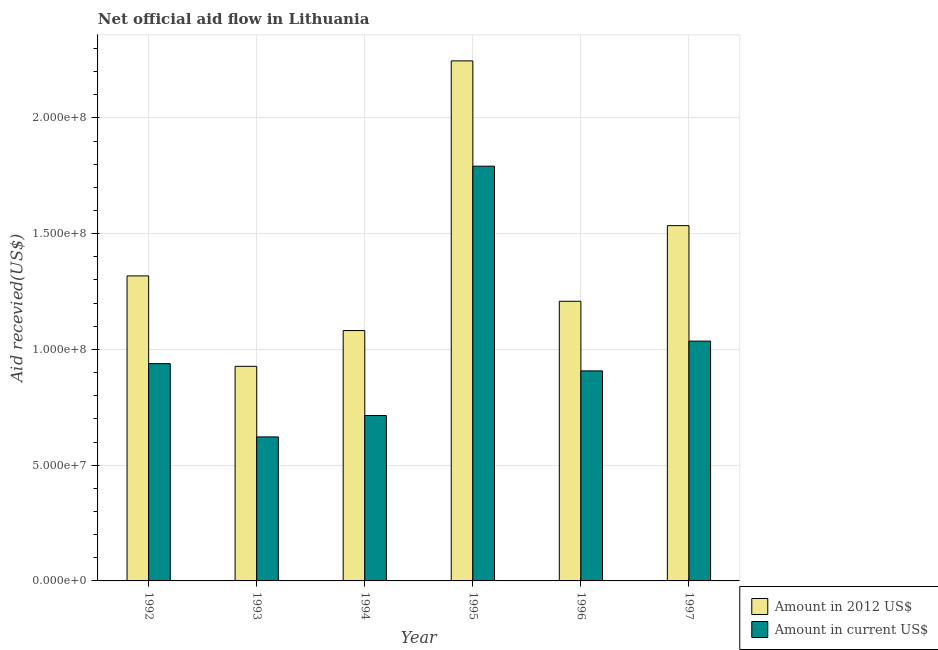How many different coloured bars are there?
Give a very brief answer. 2. Are the number of bars on each tick of the X-axis equal?
Make the answer very short. Yes. What is the label of the 4th group of bars from the left?
Keep it short and to the point. 1995. In how many cases, is the number of bars for a given year not equal to the number of legend labels?
Provide a short and direct response. 0. What is the amount of aid received(expressed in us$) in 1993?
Your answer should be very brief. 6.22e+07. Across all years, what is the maximum amount of aid received(expressed in 2012 us$)?
Make the answer very short. 2.25e+08. Across all years, what is the minimum amount of aid received(expressed in 2012 us$)?
Provide a short and direct response. 9.27e+07. In which year was the amount of aid received(expressed in 2012 us$) maximum?
Provide a short and direct response. 1995. In which year was the amount of aid received(expressed in us$) minimum?
Ensure brevity in your answer.  1993. What is the total amount of aid received(expressed in us$) in the graph?
Keep it short and to the point. 6.01e+08. What is the difference between the amount of aid received(expressed in us$) in 1994 and that in 1997?
Your answer should be very brief. -3.22e+07. What is the difference between the amount of aid received(expressed in 2012 us$) in 1992 and the amount of aid received(expressed in us$) in 1995?
Make the answer very short. -9.29e+07. What is the average amount of aid received(expressed in 2012 us$) per year?
Your answer should be compact. 1.39e+08. What is the ratio of the amount of aid received(expressed in us$) in 1995 to that in 1997?
Your answer should be compact. 1.73. Is the amount of aid received(expressed in 2012 us$) in 1992 less than that in 1995?
Provide a succinct answer. Yes. Is the difference between the amount of aid received(expressed in us$) in 1994 and 1996 greater than the difference between the amount of aid received(expressed in 2012 us$) in 1994 and 1996?
Ensure brevity in your answer.  No. What is the difference between the highest and the second highest amount of aid received(expressed in 2012 us$)?
Provide a succinct answer. 7.12e+07. What is the difference between the highest and the lowest amount of aid received(expressed in us$)?
Provide a short and direct response. 1.17e+08. In how many years, is the amount of aid received(expressed in us$) greater than the average amount of aid received(expressed in us$) taken over all years?
Your answer should be very brief. 2. Is the sum of the amount of aid received(expressed in us$) in 1992 and 1993 greater than the maximum amount of aid received(expressed in 2012 us$) across all years?
Your response must be concise. No. What does the 2nd bar from the left in 1993 represents?
Your answer should be compact. Amount in current US$. What does the 2nd bar from the right in 1993 represents?
Make the answer very short. Amount in 2012 US$. How many bars are there?
Provide a short and direct response. 12. Are all the bars in the graph horizontal?
Your response must be concise. No. What is the difference between two consecutive major ticks on the Y-axis?
Provide a succinct answer. 5.00e+07. Does the graph contain any zero values?
Your answer should be very brief. No. How many legend labels are there?
Offer a very short reply. 2. How are the legend labels stacked?
Keep it short and to the point. Vertical. What is the title of the graph?
Ensure brevity in your answer.  Net official aid flow in Lithuania. Does "Primary" appear as one of the legend labels in the graph?
Your response must be concise. No. What is the label or title of the Y-axis?
Ensure brevity in your answer.  Aid recevied(US$). What is the Aid recevied(US$) in Amount in 2012 US$ in 1992?
Your answer should be very brief. 1.32e+08. What is the Aid recevied(US$) in Amount in current US$ in 1992?
Give a very brief answer. 9.38e+07. What is the Aid recevied(US$) of Amount in 2012 US$ in 1993?
Offer a very short reply. 9.27e+07. What is the Aid recevied(US$) of Amount in current US$ in 1993?
Make the answer very short. 6.22e+07. What is the Aid recevied(US$) in Amount in 2012 US$ in 1994?
Offer a terse response. 1.08e+08. What is the Aid recevied(US$) in Amount in current US$ in 1994?
Your response must be concise. 7.14e+07. What is the Aid recevied(US$) in Amount in 2012 US$ in 1995?
Your response must be concise. 2.25e+08. What is the Aid recevied(US$) in Amount in current US$ in 1995?
Make the answer very short. 1.79e+08. What is the Aid recevied(US$) of Amount in 2012 US$ in 1996?
Your answer should be compact. 1.21e+08. What is the Aid recevied(US$) of Amount in current US$ in 1996?
Make the answer very short. 9.07e+07. What is the Aid recevied(US$) of Amount in 2012 US$ in 1997?
Offer a terse response. 1.53e+08. What is the Aid recevied(US$) of Amount in current US$ in 1997?
Offer a very short reply. 1.04e+08. Across all years, what is the maximum Aid recevied(US$) in Amount in 2012 US$?
Your answer should be very brief. 2.25e+08. Across all years, what is the maximum Aid recevied(US$) in Amount in current US$?
Offer a terse response. 1.79e+08. Across all years, what is the minimum Aid recevied(US$) of Amount in 2012 US$?
Make the answer very short. 9.27e+07. Across all years, what is the minimum Aid recevied(US$) in Amount in current US$?
Provide a succinct answer. 6.22e+07. What is the total Aid recevied(US$) of Amount in 2012 US$ in the graph?
Offer a very short reply. 8.31e+08. What is the total Aid recevied(US$) of Amount in current US$ in the graph?
Provide a succinct answer. 6.01e+08. What is the difference between the Aid recevied(US$) of Amount in 2012 US$ in 1992 and that in 1993?
Provide a short and direct response. 3.91e+07. What is the difference between the Aid recevied(US$) of Amount in current US$ in 1992 and that in 1993?
Your answer should be compact. 3.16e+07. What is the difference between the Aid recevied(US$) in Amount in 2012 US$ in 1992 and that in 1994?
Your response must be concise. 2.36e+07. What is the difference between the Aid recevied(US$) in Amount in current US$ in 1992 and that in 1994?
Keep it short and to the point. 2.24e+07. What is the difference between the Aid recevied(US$) of Amount in 2012 US$ in 1992 and that in 1995?
Provide a succinct answer. -9.29e+07. What is the difference between the Aid recevied(US$) in Amount in current US$ in 1992 and that in 1995?
Offer a very short reply. -8.53e+07. What is the difference between the Aid recevied(US$) of Amount in 2012 US$ in 1992 and that in 1996?
Ensure brevity in your answer.  1.10e+07. What is the difference between the Aid recevied(US$) in Amount in current US$ in 1992 and that in 1996?
Ensure brevity in your answer.  3.13e+06. What is the difference between the Aid recevied(US$) in Amount in 2012 US$ in 1992 and that in 1997?
Make the answer very short. -2.17e+07. What is the difference between the Aid recevied(US$) in Amount in current US$ in 1992 and that in 1997?
Offer a very short reply. -9.73e+06. What is the difference between the Aid recevied(US$) of Amount in 2012 US$ in 1993 and that in 1994?
Provide a short and direct response. -1.54e+07. What is the difference between the Aid recevied(US$) of Amount in current US$ in 1993 and that in 1994?
Keep it short and to the point. -9.23e+06. What is the difference between the Aid recevied(US$) in Amount in 2012 US$ in 1993 and that in 1995?
Make the answer very short. -1.32e+08. What is the difference between the Aid recevied(US$) in Amount in current US$ in 1993 and that in 1995?
Give a very brief answer. -1.17e+08. What is the difference between the Aid recevied(US$) of Amount in 2012 US$ in 1993 and that in 1996?
Your answer should be compact. -2.81e+07. What is the difference between the Aid recevied(US$) of Amount in current US$ in 1993 and that in 1996?
Your answer should be compact. -2.85e+07. What is the difference between the Aid recevied(US$) in Amount in 2012 US$ in 1993 and that in 1997?
Provide a succinct answer. -6.08e+07. What is the difference between the Aid recevied(US$) of Amount in current US$ in 1993 and that in 1997?
Ensure brevity in your answer.  -4.14e+07. What is the difference between the Aid recevied(US$) in Amount in 2012 US$ in 1994 and that in 1995?
Provide a short and direct response. -1.16e+08. What is the difference between the Aid recevied(US$) in Amount in current US$ in 1994 and that in 1995?
Make the answer very short. -1.08e+08. What is the difference between the Aid recevied(US$) of Amount in 2012 US$ in 1994 and that in 1996?
Your answer should be very brief. -1.26e+07. What is the difference between the Aid recevied(US$) in Amount in current US$ in 1994 and that in 1996?
Make the answer very short. -1.93e+07. What is the difference between the Aid recevied(US$) in Amount in 2012 US$ in 1994 and that in 1997?
Make the answer very short. -4.53e+07. What is the difference between the Aid recevied(US$) of Amount in current US$ in 1994 and that in 1997?
Ensure brevity in your answer.  -3.22e+07. What is the difference between the Aid recevied(US$) of Amount in 2012 US$ in 1995 and that in 1996?
Provide a succinct answer. 1.04e+08. What is the difference between the Aid recevied(US$) of Amount in current US$ in 1995 and that in 1996?
Ensure brevity in your answer.  8.84e+07. What is the difference between the Aid recevied(US$) in Amount in 2012 US$ in 1995 and that in 1997?
Your answer should be compact. 7.12e+07. What is the difference between the Aid recevied(US$) of Amount in current US$ in 1995 and that in 1997?
Your answer should be compact. 7.56e+07. What is the difference between the Aid recevied(US$) in Amount in 2012 US$ in 1996 and that in 1997?
Provide a short and direct response. -3.27e+07. What is the difference between the Aid recevied(US$) in Amount in current US$ in 1996 and that in 1997?
Your answer should be very brief. -1.29e+07. What is the difference between the Aid recevied(US$) of Amount in 2012 US$ in 1992 and the Aid recevied(US$) of Amount in current US$ in 1993?
Your response must be concise. 6.96e+07. What is the difference between the Aid recevied(US$) of Amount in 2012 US$ in 1992 and the Aid recevied(US$) of Amount in current US$ in 1994?
Give a very brief answer. 6.03e+07. What is the difference between the Aid recevied(US$) in Amount in 2012 US$ in 1992 and the Aid recevied(US$) in Amount in current US$ in 1995?
Keep it short and to the point. -4.74e+07. What is the difference between the Aid recevied(US$) of Amount in 2012 US$ in 1992 and the Aid recevied(US$) of Amount in current US$ in 1996?
Provide a short and direct response. 4.10e+07. What is the difference between the Aid recevied(US$) in Amount in 2012 US$ in 1992 and the Aid recevied(US$) in Amount in current US$ in 1997?
Offer a very short reply. 2.82e+07. What is the difference between the Aid recevied(US$) of Amount in 2012 US$ in 1993 and the Aid recevied(US$) of Amount in current US$ in 1994?
Provide a short and direct response. 2.13e+07. What is the difference between the Aid recevied(US$) of Amount in 2012 US$ in 1993 and the Aid recevied(US$) of Amount in current US$ in 1995?
Keep it short and to the point. -8.64e+07. What is the difference between the Aid recevied(US$) in Amount in 2012 US$ in 1993 and the Aid recevied(US$) in Amount in current US$ in 1996?
Ensure brevity in your answer.  1.97e+06. What is the difference between the Aid recevied(US$) of Amount in 2012 US$ in 1993 and the Aid recevied(US$) of Amount in current US$ in 1997?
Your response must be concise. -1.09e+07. What is the difference between the Aid recevied(US$) of Amount in 2012 US$ in 1994 and the Aid recevied(US$) of Amount in current US$ in 1995?
Offer a very short reply. -7.10e+07. What is the difference between the Aid recevied(US$) in Amount in 2012 US$ in 1994 and the Aid recevied(US$) in Amount in current US$ in 1996?
Give a very brief answer. 1.74e+07. What is the difference between the Aid recevied(US$) of Amount in 2012 US$ in 1994 and the Aid recevied(US$) of Amount in current US$ in 1997?
Offer a terse response. 4.56e+06. What is the difference between the Aid recevied(US$) in Amount in 2012 US$ in 1995 and the Aid recevied(US$) in Amount in current US$ in 1996?
Offer a terse response. 1.34e+08. What is the difference between the Aid recevied(US$) of Amount in 2012 US$ in 1995 and the Aid recevied(US$) of Amount in current US$ in 1997?
Your answer should be compact. 1.21e+08. What is the difference between the Aid recevied(US$) in Amount in 2012 US$ in 1996 and the Aid recevied(US$) in Amount in current US$ in 1997?
Give a very brief answer. 1.72e+07. What is the average Aid recevied(US$) in Amount in 2012 US$ per year?
Offer a terse response. 1.39e+08. What is the average Aid recevied(US$) in Amount in current US$ per year?
Your answer should be very brief. 1.00e+08. In the year 1992, what is the difference between the Aid recevied(US$) in Amount in 2012 US$ and Aid recevied(US$) in Amount in current US$?
Your answer should be compact. 3.79e+07. In the year 1993, what is the difference between the Aid recevied(US$) in Amount in 2012 US$ and Aid recevied(US$) in Amount in current US$?
Provide a succinct answer. 3.05e+07. In the year 1994, what is the difference between the Aid recevied(US$) of Amount in 2012 US$ and Aid recevied(US$) of Amount in current US$?
Keep it short and to the point. 3.67e+07. In the year 1995, what is the difference between the Aid recevied(US$) of Amount in 2012 US$ and Aid recevied(US$) of Amount in current US$?
Give a very brief answer. 4.55e+07. In the year 1996, what is the difference between the Aid recevied(US$) of Amount in 2012 US$ and Aid recevied(US$) of Amount in current US$?
Your response must be concise. 3.01e+07. In the year 1997, what is the difference between the Aid recevied(US$) of Amount in 2012 US$ and Aid recevied(US$) of Amount in current US$?
Keep it short and to the point. 4.99e+07. What is the ratio of the Aid recevied(US$) in Amount in 2012 US$ in 1992 to that in 1993?
Offer a very short reply. 1.42. What is the ratio of the Aid recevied(US$) of Amount in current US$ in 1992 to that in 1993?
Give a very brief answer. 1.51. What is the ratio of the Aid recevied(US$) of Amount in 2012 US$ in 1992 to that in 1994?
Keep it short and to the point. 1.22. What is the ratio of the Aid recevied(US$) in Amount in current US$ in 1992 to that in 1994?
Provide a short and direct response. 1.31. What is the ratio of the Aid recevied(US$) in Amount in 2012 US$ in 1992 to that in 1995?
Offer a very short reply. 0.59. What is the ratio of the Aid recevied(US$) of Amount in current US$ in 1992 to that in 1995?
Give a very brief answer. 0.52. What is the ratio of the Aid recevied(US$) in Amount in 2012 US$ in 1992 to that in 1996?
Your answer should be very brief. 1.09. What is the ratio of the Aid recevied(US$) of Amount in current US$ in 1992 to that in 1996?
Keep it short and to the point. 1.03. What is the ratio of the Aid recevied(US$) of Amount in 2012 US$ in 1992 to that in 1997?
Give a very brief answer. 0.86. What is the ratio of the Aid recevied(US$) of Amount in current US$ in 1992 to that in 1997?
Your answer should be very brief. 0.91. What is the ratio of the Aid recevied(US$) in Amount in current US$ in 1993 to that in 1994?
Your response must be concise. 0.87. What is the ratio of the Aid recevied(US$) of Amount in 2012 US$ in 1993 to that in 1995?
Keep it short and to the point. 0.41. What is the ratio of the Aid recevied(US$) of Amount in current US$ in 1993 to that in 1995?
Your answer should be very brief. 0.35. What is the ratio of the Aid recevied(US$) of Amount in 2012 US$ in 1993 to that in 1996?
Provide a succinct answer. 0.77. What is the ratio of the Aid recevied(US$) of Amount in current US$ in 1993 to that in 1996?
Provide a short and direct response. 0.69. What is the ratio of the Aid recevied(US$) in Amount in 2012 US$ in 1993 to that in 1997?
Your answer should be compact. 0.6. What is the ratio of the Aid recevied(US$) in Amount in current US$ in 1993 to that in 1997?
Offer a terse response. 0.6. What is the ratio of the Aid recevied(US$) of Amount in 2012 US$ in 1994 to that in 1995?
Your answer should be compact. 0.48. What is the ratio of the Aid recevied(US$) in Amount in current US$ in 1994 to that in 1995?
Your answer should be very brief. 0.4. What is the ratio of the Aid recevied(US$) of Amount in 2012 US$ in 1994 to that in 1996?
Offer a very short reply. 0.9. What is the ratio of the Aid recevied(US$) in Amount in current US$ in 1994 to that in 1996?
Keep it short and to the point. 0.79. What is the ratio of the Aid recevied(US$) of Amount in 2012 US$ in 1994 to that in 1997?
Make the answer very short. 0.7. What is the ratio of the Aid recevied(US$) in Amount in current US$ in 1994 to that in 1997?
Your answer should be compact. 0.69. What is the ratio of the Aid recevied(US$) in Amount in 2012 US$ in 1995 to that in 1996?
Provide a succinct answer. 1.86. What is the ratio of the Aid recevied(US$) of Amount in current US$ in 1995 to that in 1996?
Make the answer very short. 1.97. What is the ratio of the Aid recevied(US$) in Amount in 2012 US$ in 1995 to that in 1997?
Provide a short and direct response. 1.46. What is the ratio of the Aid recevied(US$) of Amount in current US$ in 1995 to that in 1997?
Make the answer very short. 1.73. What is the ratio of the Aid recevied(US$) in Amount in 2012 US$ in 1996 to that in 1997?
Your answer should be compact. 0.79. What is the ratio of the Aid recevied(US$) in Amount in current US$ in 1996 to that in 1997?
Provide a succinct answer. 0.88. What is the difference between the highest and the second highest Aid recevied(US$) of Amount in 2012 US$?
Offer a very short reply. 7.12e+07. What is the difference between the highest and the second highest Aid recevied(US$) of Amount in current US$?
Keep it short and to the point. 7.56e+07. What is the difference between the highest and the lowest Aid recevied(US$) in Amount in 2012 US$?
Provide a short and direct response. 1.32e+08. What is the difference between the highest and the lowest Aid recevied(US$) of Amount in current US$?
Your answer should be compact. 1.17e+08. 